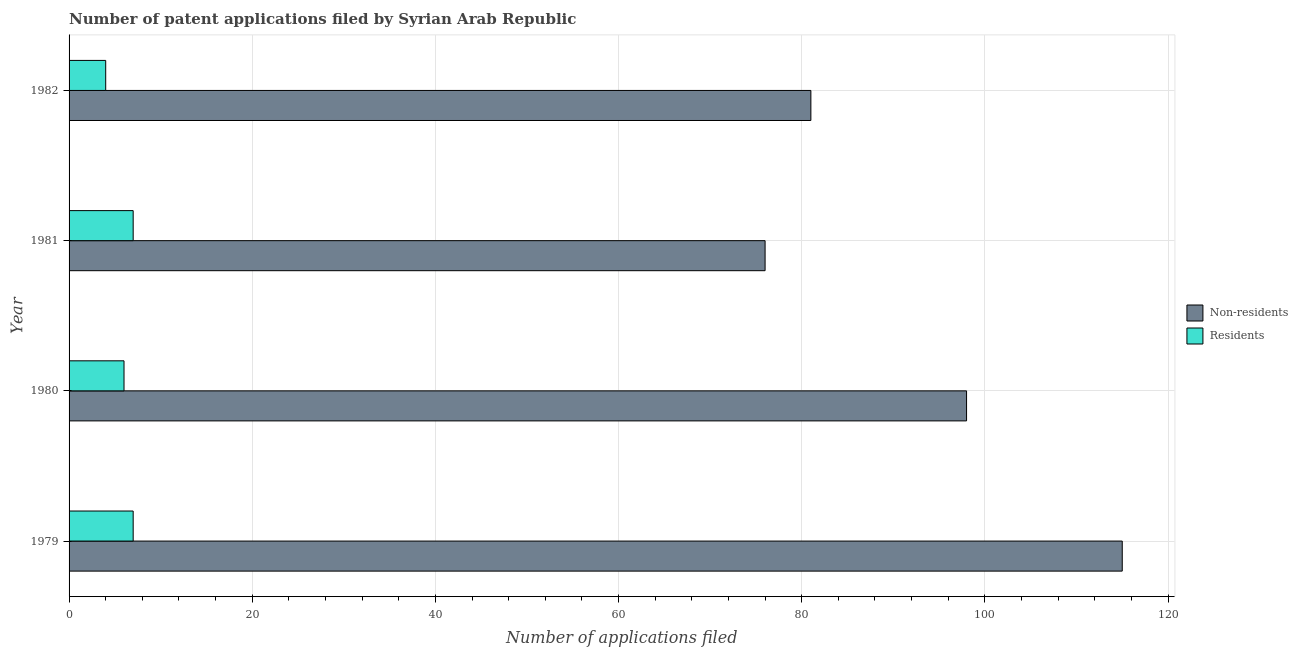Are the number of bars per tick equal to the number of legend labels?
Your answer should be compact. Yes. Are the number of bars on each tick of the Y-axis equal?
Make the answer very short. Yes. How many bars are there on the 2nd tick from the top?
Your answer should be very brief. 2. How many bars are there on the 4th tick from the bottom?
Offer a very short reply. 2. What is the label of the 2nd group of bars from the top?
Ensure brevity in your answer.  1981. In how many cases, is the number of bars for a given year not equal to the number of legend labels?
Ensure brevity in your answer.  0. What is the number of patent applications by residents in 1979?
Your response must be concise. 7. Across all years, what is the maximum number of patent applications by non residents?
Ensure brevity in your answer.  115. Across all years, what is the minimum number of patent applications by residents?
Provide a short and direct response. 4. In which year was the number of patent applications by non residents maximum?
Your answer should be compact. 1979. What is the total number of patent applications by non residents in the graph?
Your answer should be compact. 370. What is the difference between the number of patent applications by residents in 1981 and that in 1982?
Keep it short and to the point. 3. What is the difference between the number of patent applications by residents in 1981 and the number of patent applications by non residents in 1980?
Your answer should be very brief. -91. What is the average number of patent applications by residents per year?
Offer a terse response. 6. In the year 1982, what is the difference between the number of patent applications by non residents and number of patent applications by residents?
Your answer should be compact. 77. In how many years, is the number of patent applications by non residents greater than 24 ?
Make the answer very short. 4. What is the ratio of the number of patent applications by residents in 1980 to that in 1982?
Your answer should be very brief. 1.5. Is the number of patent applications by residents in 1981 less than that in 1982?
Offer a very short reply. No. Is the difference between the number of patent applications by residents in 1979 and 1981 greater than the difference between the number of patent applications by non residents in 1979 and 1981?
Keep it short and to the point. No. What is the difference between the highest and the second highest number of patent applications by residents?
Your response must be concise. 0. What is the difference between the highest and the lowest number of patent applications by residents?
Your answer should be very brief. 3. What does the 2nd bar from the top in 1980 represents?
Your answer should be compact. Non-residents. What does the 2nd bar from the bottom in 1982 represents?
Your answer should be compact. Residents. How many bars are there?
Keep it short and to the point. 8. Are all the bars in the graph horizontal?
Your answer should be compact. Yes. How many years are there in the graph?
Your answer should be compact. 4. Are the values on the major ticks of X-axis written in scientific E-notation?
Give a very brief answer. No. Does the graph contain any zero values?
Give a very brief answer. No. How many legend labels are there?
Ensure brevity in your answer.  2. What is the title of the graph?
Your response must be concise. Number of patent applications filed by Syrian Arab Republic. Does "Current US$" appear as one of the legend labels in the graph?
Your answer should be very brief. No. What is the label or title of the X-axis?
Your answer should be compact. Number of applications filed. What is the Number of applications filed in Non-residents in 1979?
Your response must be concise. 115. What is the Number of applications filed in Residents in 1979?
Keep it short and to the point. 7. What is the Number of applications filed of Residents in 1980?
Your answer should be very brief. 6. What is the Number of applications filed of Residents in 1981?
Offer a terse response. 7. What is the Number of applications filed in Non-residents in 1982?
Your answer should be very brief. 81. What is the Number of applications filed in Residents in 1982?
Make the answer very short. 4. Across all years, what is the maximum Number of applications filed of Non-residents?
Your response must be concise. 115. What is the total Number of applications filed of Non-residents in the graph?
Your answer should be compact. 370. What is the total Number of applications filed of Residents in the graph?
Your answer should be very brief. 24. What is the difference between the Number of applications filed in Non-residents in 1979 and that in 1980?
Provide a succinct answer. 17. What is the difference between the Number of applications filed of Residents in 1979 and that in 1980?
Your answer should be very brief. 1. What is the difference between the Number of applications filed in Non-residents in 1979 and that in 1981?
Provide a succinct answer. 39. What is the difference between the Number of applications filed of Residents in 1979 and that in 1982?
Your response must be concise. 3. What is the difference between the Number of applications filed of Residents in 1980 and that in 1981?
Offer a terse response. -1. What is the difference between the Number of applications filed in Non-residents in 1979 and the Number of applications filed in Residents in 1980?
Ensure brevity in your answer.  109. What is the difference between the Number of applications filed of Non-residents in 1979 and the Number of applications filed of Residents in 1981?
Provide a succinct answer. 108. What is the difference between the Number of applications filed in Non-residents in 1979 and the Number of applications filed in Residents in 1982?
Offer a very short reply. 111. What is the difference between the Number of applications filed of Non-residents in 1980 and the Number of applications filed of Residents in 1981?
Offer a very short reply. 91. What is the difference between the Number of applications filed of Non-residents in 1980 and the Number of applications filed of Residents in 1982?
Offer a very short reply. 94. What is the difference between the Number of applications filed of Non-residents in 1981 and the Number of applications filed of Residents in 1982?
Make the answer very short. 72. What is the average Number of applications filed in Non-residents per year?
Give a very brief answer. 92.5. In the year 1979, what is the difference between the Number of applications filed in Non-residents and Number of applications filed in Residents?
Provide a short and direct response. 108. In the year 1980, what is the difference between the Number of applications filed in Non-residents and Number of applications filed in Residents?
Keep it short and to the point. 92. In the year 1981, what is the difference between the Number of applications filed in Non-residents and Number of applications filed in Residents?
Your response must be concise. 69. In the year 1982, what is the difference between the Number of applications filed in Non-residents and Number of applications filed in Residents?
Provide a succinct answer. 77. What is the ratio of the Number of applications filed of Non-residents in 1979 to that in 1980?
Give a very brief answer. 1.17. What is the ratio of the Number of applications filed in Non-residents in 1979 to that in 1981?
Offer a very short reply. 1.51. What is the ratio of the Number of applications filed of Residents in 1979 to that in 1981?
Keep it short and to the point. 1. What is the ratio of the Number of applications filed of Non-residents in 1979 to that in 1982?
Give a very brief answer. 1.42. What is the ratio of the Number of applications filed in Non-residents in 1980 to that in 1981?
Ensure brevity in your answer.  1.29. What is the ratio of the Number of applications filed of Residents in 1980 to that in 1981?
Provide a short and direct response. 0.86. What is the ratio of the Number of applications filed of Non-residents in 1980 to that in 1982?
Your answer should be very brief. 1.21. What is the ratio of the Number of applications filed in Residents in 1980 to that in 1982?
Make the answer very short. 1.5. What is the ratio of the Number of applications filed in Non-residents in 1981 to that in 1982?
Your answer should be very brief. 0.94. What is the difference between the highest and the lowest Number of applications filed of Non-residents?
Ensure brevity in your answer.  39. What is the difference between the highest and the lowest Number of applications filed of Residents?
Ensure brevity in your answer.  3. 